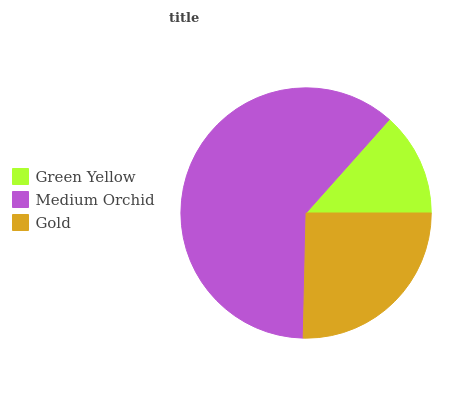Is Green Yellow the minimum?
Answer yes or no. Yes. Is Medium Orchid the maximum?
Answer yes or no. Yes. Is Gold the minimum?
Answer yes or no. No. Is Gold the maximum?
Answer yes or no. No. Is Medium Orchid greater than Gold?
Answer yes or no. Yes. Is Gold less than Medium Orchid?
Answer yes or no. Yes. Is Gold greater than Medium Orchid?
Answer yes or no. No. Is Medium Orchid less than Gold?
Answer yes or no. No. Is Gold the high median?
Answer yes or no. Yes. Is Gold the low median?
Answer yes or no. Yes. Is Medium Orchid the high median?
Answer yes or no. No. Is Medium Orchid the low median?
Answer yes or no. No. 